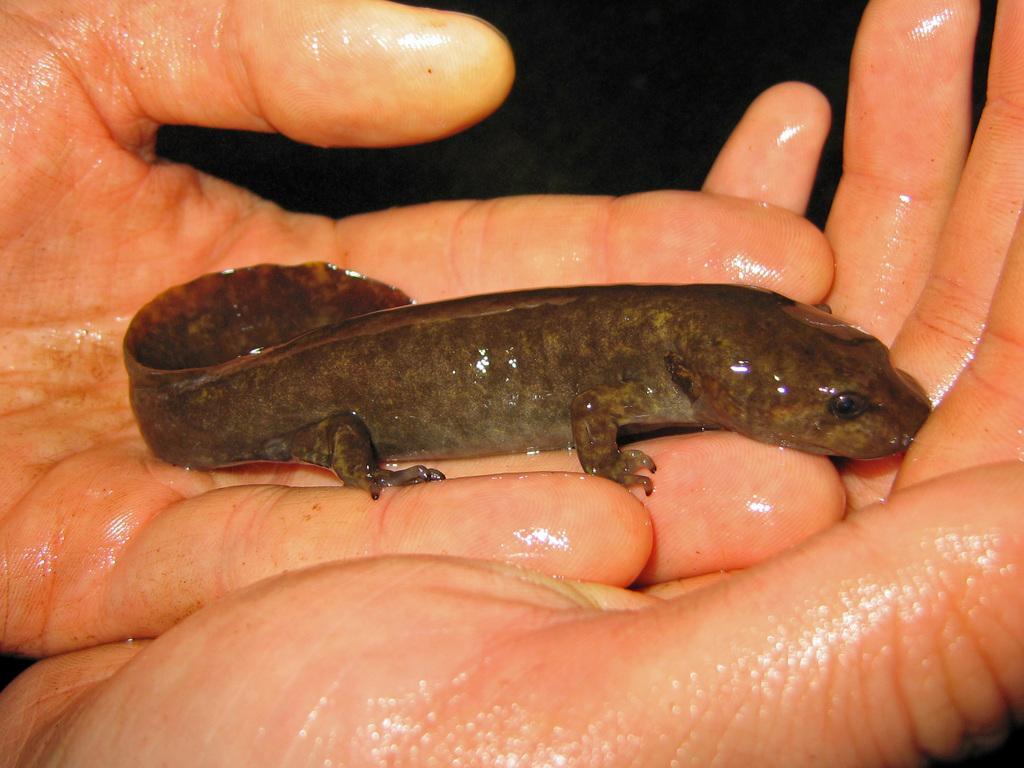How would you summarize this image in a sentence or two? There is a reptile on the hands of a person. 